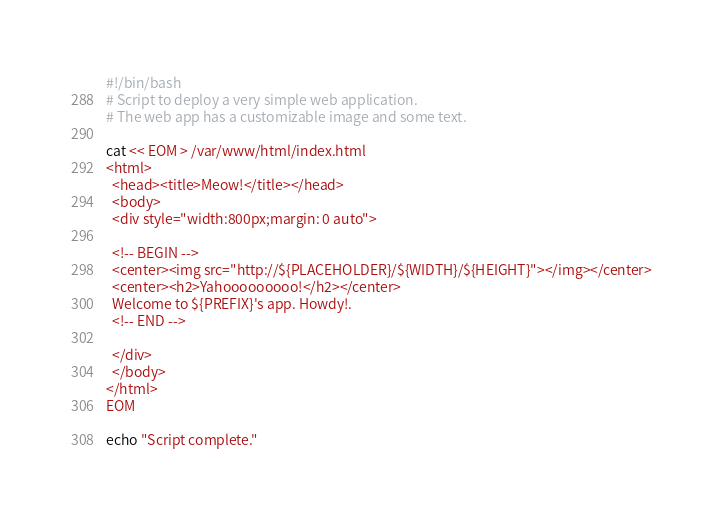Convert code to text. <code><loc_0><loc_0><loc_500><loc_500><_Bash_>#!/bin/bash
# Script to deploy a very simple web application.
# The web app has a customizable image and some text.

cat << EOM > /var/www/html/index.html
<html>
  <head><title>Meow!</title></head>
  <body>
  <div style="width:800px;margin: 0 auto">

  <!-- BEGIN -->
  <center><img src="http://${PLACEHOLDER}/${WIDTH}/${HEIGHT}"></img></center>
  <center><h2>Yahooooooooo!</h2></center>
  Welcome to ${PREFIX}'s app. Howdy!. 
  <!-- END -->
  
  </div>
  </body>
</html>
EOM

echo "Script complete."
</code> 